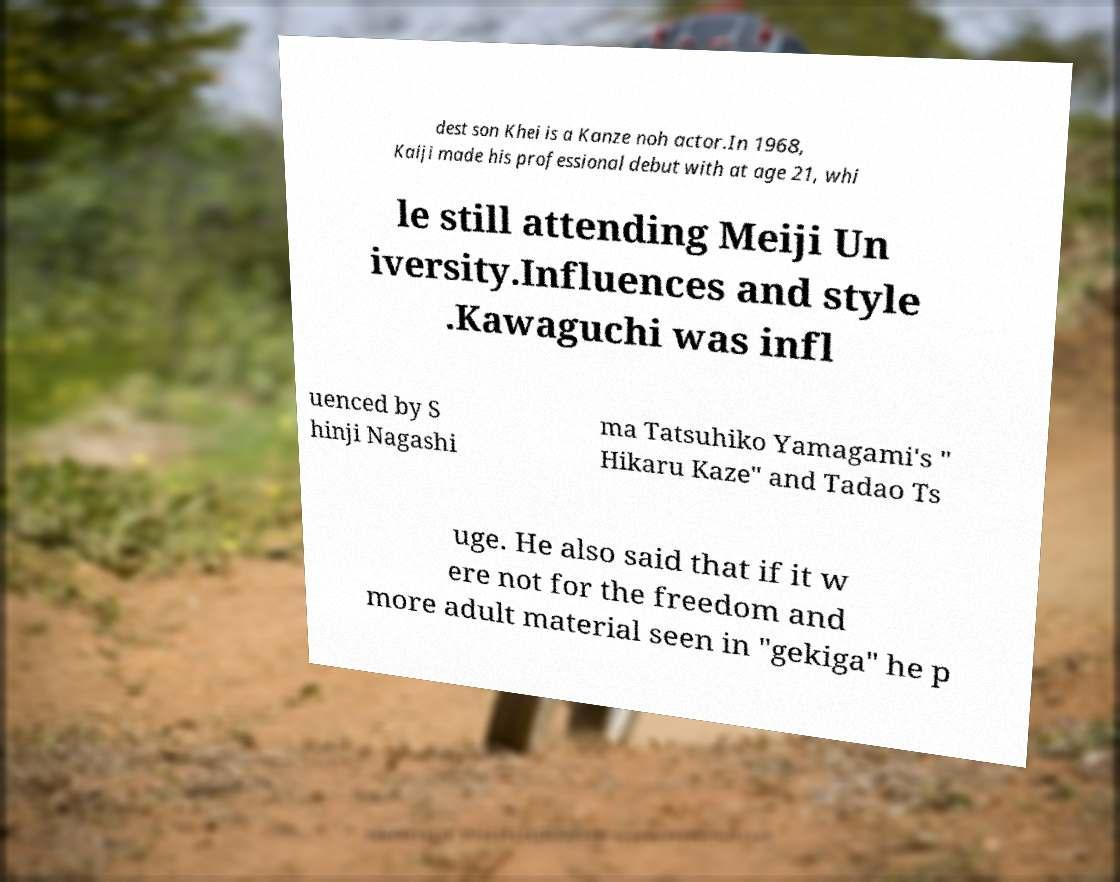What messages or text are displayed in this image? I need them in a readable, typed format. dest son Khei is a Kanze noh actor.In 1968, Kaiji made his professional debut with at age 21, whi le still attending Meiji Un iversity.Influences and style .Kawaguchi was infl uenced by S hinji Nagashi ma Tatsuhiko Yamagami's " Hikaru Kaze" and Tadao Ts uge. He also said that if it w ere not for the freedom and more adult material seen in "gekiga" he p 